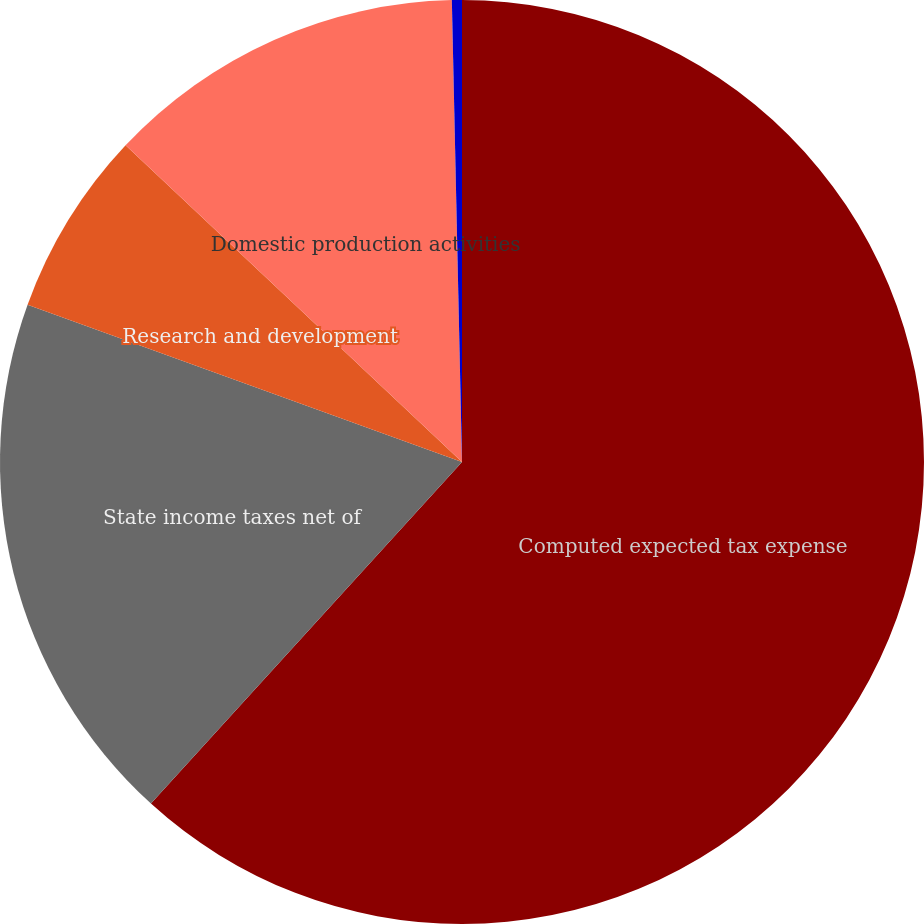Convert chart. <chart><loc_0><loc_0><loc_500><loc_500><pie_chart><fcel>Computed expected tax expense<fcel>State income taxes net of<fcel>Research and development<fcel>Domestic production activities<fcel>Other (net)<nl><fcel>61.75%<fcel>18.77%<fcel>6.49%<fcel>12.63%<fcel>0.35%<nl></chart> 